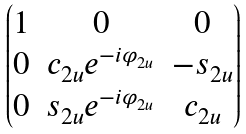Convert formula to latex. <formula><loc_0><loc_0><loc_500><loc_500>\begin{pmatrix} 1 & 0 & 0 \\ 0 & c _ { 2 u } e ^ { - i \varphi _ { 2 u } } & - s _ { 2 u } \\ 0 & s _ { 2 u } e ^ { - i \varphi _ { 2 u } } & c _ { 2 u } \end{pmatrix}</formula> 